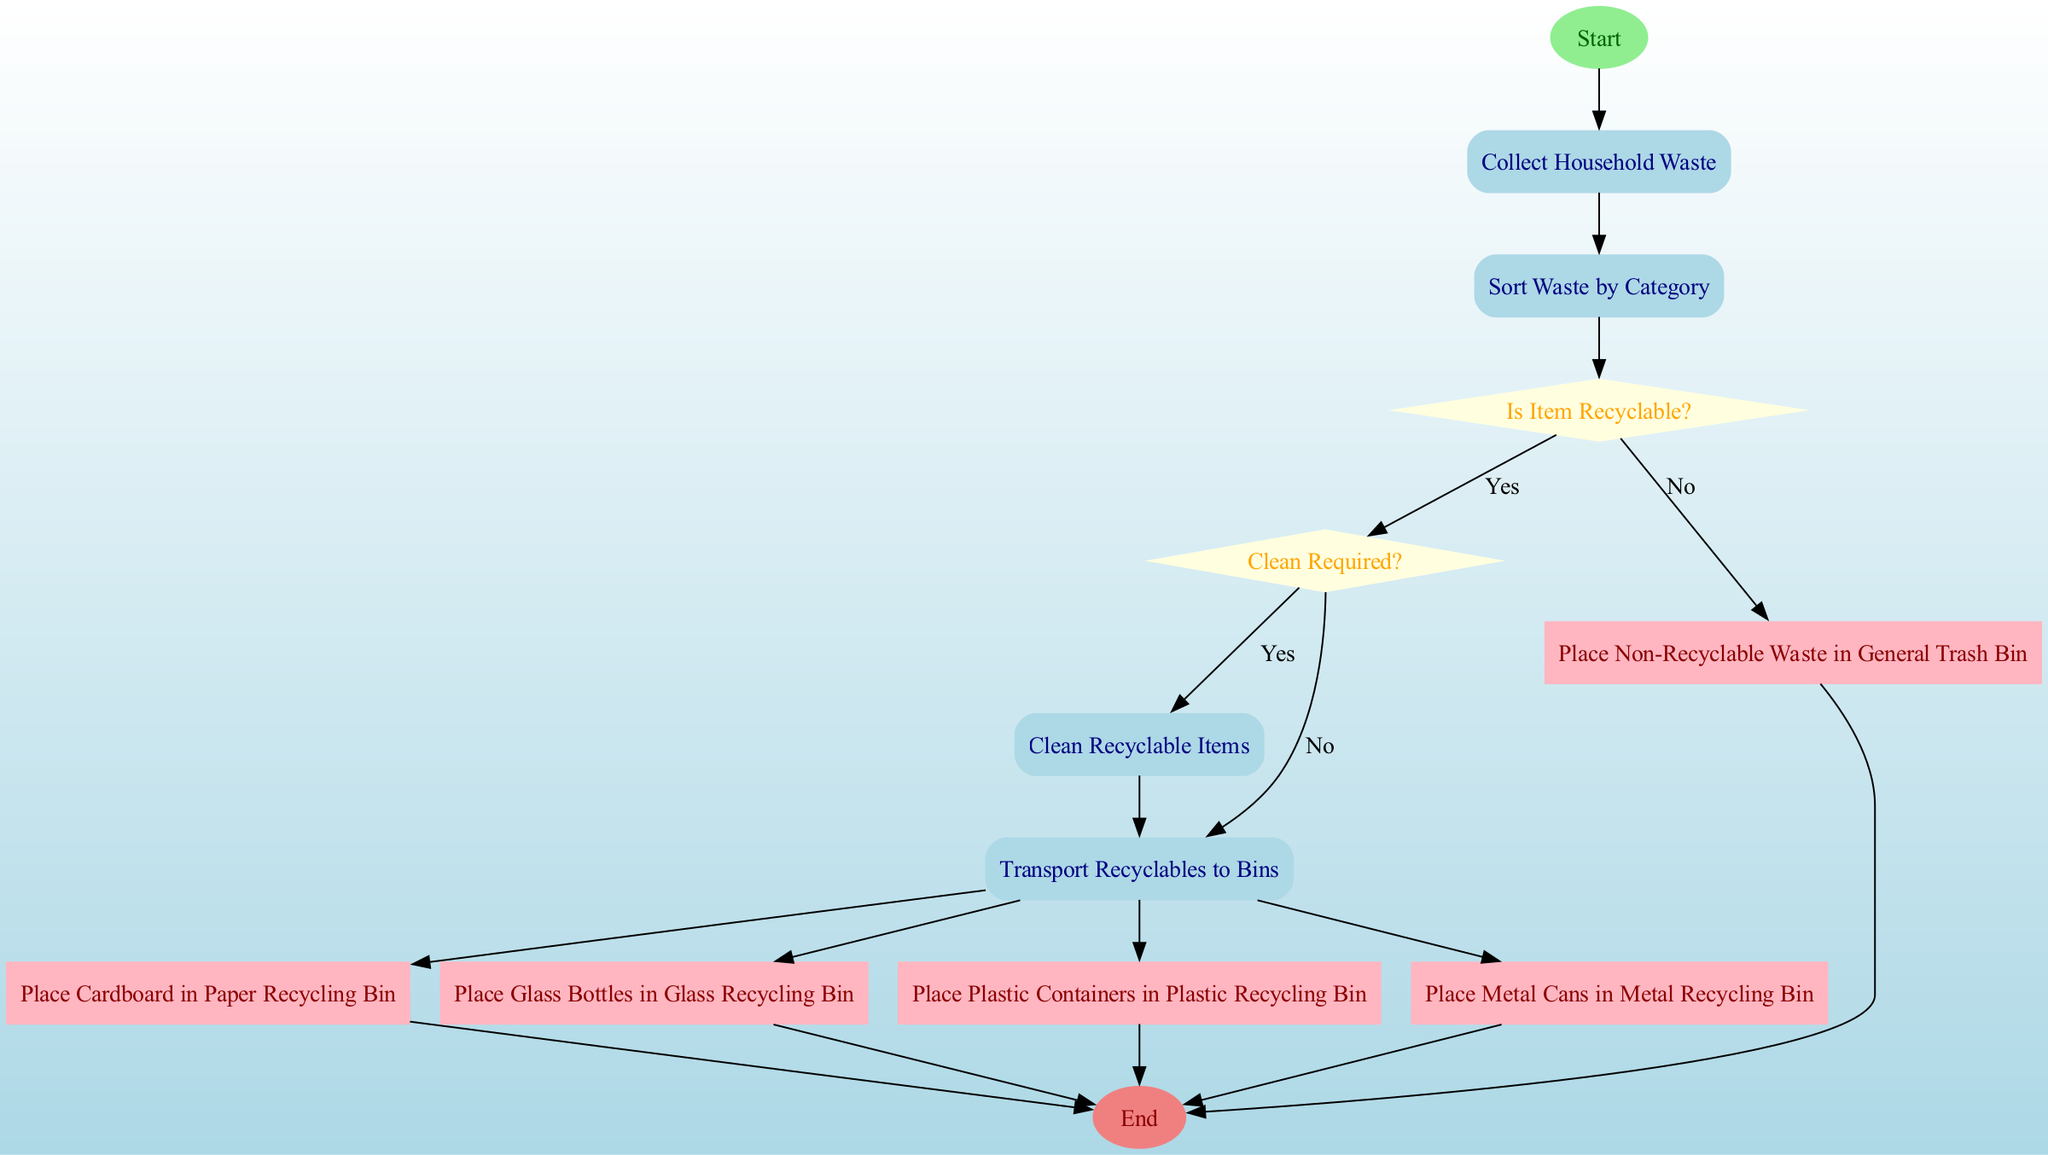What is the first activity in the diagram? The first activity is shown directly after the start node, which is labeled "Collect Household Waste".
Answer: Collect Household Waste How many activities are represented in the diagram? The diagram includes four distinct activities, each outlined in a rectangle.
Answer: 4 What follows the decision node labeled "Is Item Recyclable?" if the answer is "Yes"? If the answer is "Yes", the flow goes to the next decision labeled "Clean Required?".
Answer: Clean Required? How many actions follow the activity "Transport Recyclables to Bins"? There are five actions that follow the activity "Transport Recyclables to Bins", each leading to a different recycling bin.
Answer: 5 What type of node comes after the decision "Clean Required?" if the answer is "Yes"? The node that follows is the activity labeled "Clean Recyclable Items", which indicates the necessary action if cleaning is required.
Answer: Clean Recyclable Items Which bin does "Cardboard" go into according to the actions? The action specifies that "Cardboard" is placed in the "Paper Recycling Bin".
Answer: Paper Recycling Bin What is the final node in the diagram? The final node is labeled "End", indicating the completion of the recycling process flow.
Answer: End What happens to non-recyclable waste according to the actions? Non-recyclable waste is directed to the "General Trash Bin" as indicated in the action.
Answer: General Trash Bin What type of decision node is associated with the cleaning requirement? The decision node "Clean Required?" is categorized as a diamond-shaped node, which represents a branching decision point.
Answer: Diamond-shaped node 